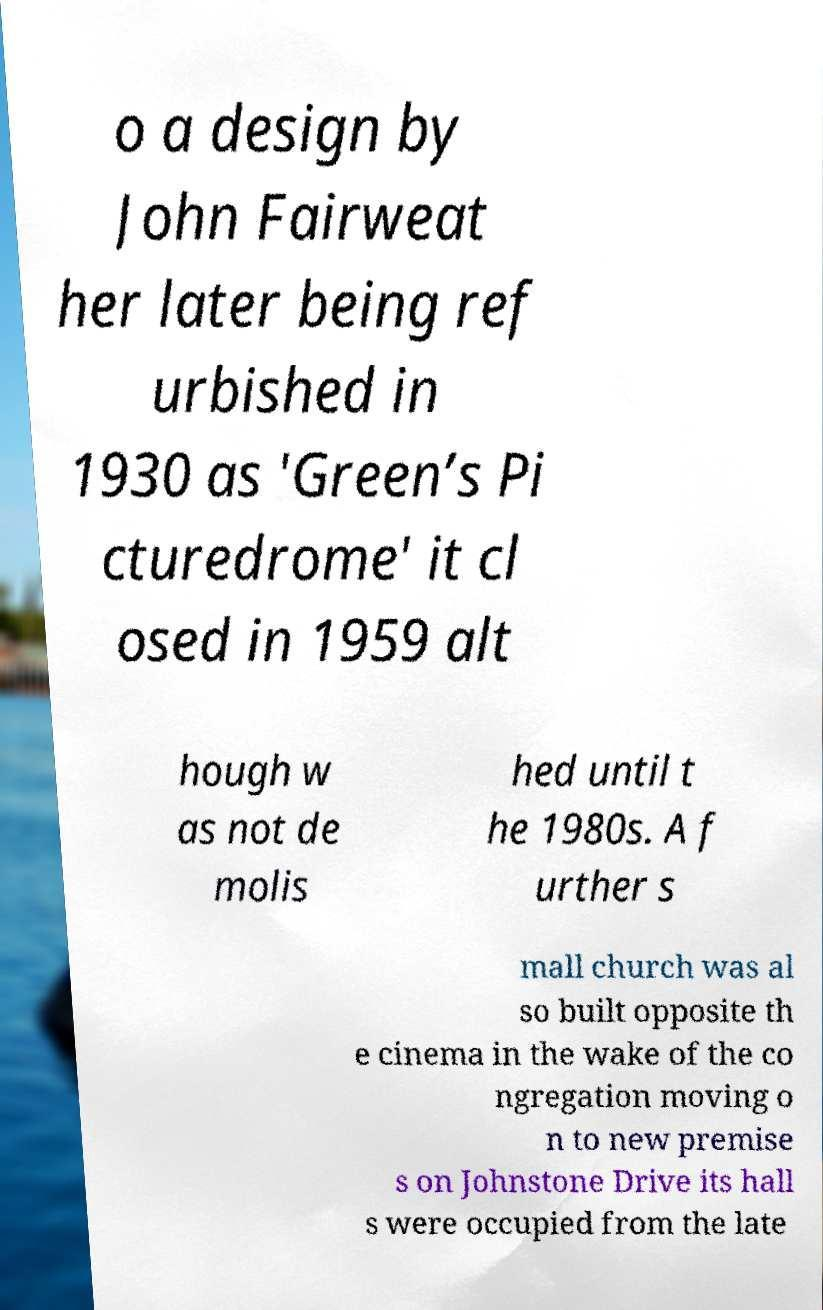Can you read and provide the text displayed in the image?This photo seems to have some interesting text. Can you extract and type it out for me? o a design by John Fairweat her later being ref urbished in 1930 as 'Green’s Pi cturedrome' it cl osed in 1959 alt hough w as not de molis hed until t he 1980s. A f urther s mall church was al so built opposite th e cinema in the wake of the co ngregation moving o n to new premise s on Johnstone Drive its hall s were occupied from the late 